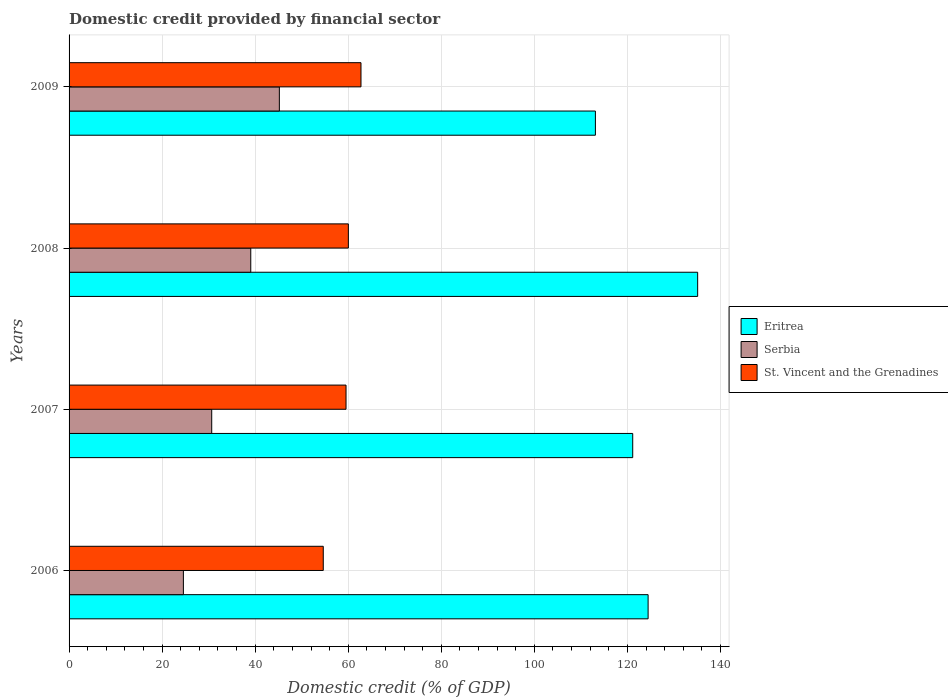How many different coloured bars are there?
Your answer should be compact. 3. How many groups of bars are there?
Provide a succinct answer. 4. Are the number of bars per tick equal to the number of legend labels?
Ensure brevity in your answer.  Yes. How many bars are there on the 4th tick from the top?
Offer a very short reply. 3. What is the label of the 1st group of bars from the top?
Keep it short and to the point. 2009. In how many cases, is the number of bars for a given year not equal to the number of legend labels?
Provide a succinct answer. 0. What is the domestic credit in Serbia in 2006?
Keep it short and to the point. 24.57. Across all years, what is the maximum domestic credit in Serbia?
Give a very brief answer. 45.2. Across all years, what is the minimum domestic credit in Eritrea?
Offer a very short reply. 113.12. What is the total domestic credit in Serbia in the graph?
Keep it short and to the point. 139.47. What is the difference between the domestic credit in Eritrea in 2008 and that in 2009?
Offer a very short reply. 21.98. What is the difference between the domestic credit in Eritrea in 2009 and the domestic credit in St. Vincent and the Grenadines in 2007?
Make the answer very short. 53.6. What is the average domestic credit in Eritrea per year?
Offer a very short reply. 123.45. In the year 2008, what is the difference between the domestic credit in Serbia and domestic credit in Eritrea?
Your response must be concise. -96.05. In how many years, is the domestic credit in Eritrea greater than 32 %?
Keep it short and to the point. 4. What is the ratio of the domestic credit in Serbia in 2008 to that in 2009?
Provide a succinct answer. 0.86. Is the difference between the domestic credit in Serbia in 2008 and 2009 greater than the difference between the domestic credit in Eritrea in 2008 and 2009?
Your answer should be very brief. No. What is the difference between the highest and the second highest domestic credit in Serbia?
Give a very brief answer. 6.14. What is the difference between the highest and the lowest domestic credit in St. Vincent and the Grenadines?
Offer a very short reply. 8.11. What does the 1st bar from the top in 2006 represents?
Ensure brevity in your answer.  St. Vincent and the Grenadines. What does the 1st bar from the bottom in 2007 represents?
Provide a short and direct response. Eritrea. How many bars are there?
Offer a terse response. 12. Does the graph contain any zero values?
Offer a terse response. No. Does the graph contain grids?
Offer a terse response. Yes. How many legend labels are there?
Ensure brevity in your answer.  3. What is the title of the graph?
Offer a terse response. Domestic credit provided by financial sector. Does "Malta" appear as one of the legend labels in the graph?
Give a very brief answer. No. What is the label or title of the X-axis?
Provide a short and direct response. Domestic credit (% of GDP). What is the Domestic credit (% of GDP) in Eritrea in 2006?
Ensure brevity in your answer.  124.45. What is the Domestic credit (% of GDP) of Serbia in 2006?
Provide a short and direct response. 24.57. What is the Domestic credit (% of GDP) of St. Vincent and the Grenadines in 2006?
Give a very brief answer. 54.63. What is the Domestic credit (% of GDP) in Eritrea in 2007?
Keep it short and to the point. 121.14. What is the Domestic credit (% of GDP) of Serbia in 2007?
Provide a short and direct response. 30.66. What is the Domestic credit (% of GDP) in St. Vincent and the Grenadines in 2007?
Your answer should be compact. 59.53. What is the Domestic credit (% of GDP) of Eritrea in 2008?
Offer a very short reply. 135.1. What is the Domestic credit (% of GDP) of Serbia in 2008?
Offer a very short reply. 39.05. What is the Domestic credit (% of GDP) in St. Vincent and the Grenadines in 2008?
Ensure brevity in your answer.  60.03. What is the Domestic credit (% of GDP) in Eritrea in 2009?
Keep it short and to the point. 113.12. What is the Domestic credit (% of GDP) in Serbia in 2009?
Ensure brevity in your answer.  45.2. What is the Domestic credit (% of GDP) in St. Vincent and the Grenadines in 2009?
Provide a succinct answer. 62.74. Across all years, what is the maximum Domestic credit (% of GDP) in Eritrea?
Make the answer very short. 135.1. Across all years, what is the maximum Domestic credit (% of GDP) in Serbia?
Keep it short and to the point. 45.2. Across all years, what is the maximum Domestic credit (% of GDP) in St. Vincent and the Grenadines?
Give a very brief answer. 62.74. Across all years, what is the minimum Domestic credit (% of GDP) of Eritrea?
Ensure brevity in your answer.  113.12. Across all years, what is the minimum Domestic credit (% of GDP) in Serbia?
Give a very brief answer. 24.57. Across all years, what is the minimum Domestic credit (% of GDP) in St. Vincent and the Grenadines?
Your answer should be compact. 54.63. What is the total Domestic credit (% of GDP) in Eritrea in the graph?
Make the answer very short. 493.82. What is the total Domestic credit (% of GDP) of Serbia in the graph?
Your answer should be very brief. 139.47. What is the total Domestic credit (% of GDP) in St. Vincent and the Grenadines in the graph?
Your response must be concise. 236.93. What is the difference between the Domestic credit (% of GDP) in Eritrea in 2006 and that in 2007?
Provide a succinct answer. 3.31. What is the difference between the Domestic credit (% of GDP) of Serbia in 2006 and that in 2007?
Offer a terse response. -6.09. What is the difference between the Domestic credit (% of GDP) in St. Vincent and the Grenadines in 2006 and that in 2007?
Provide a short and direct response. -4.89. What is the difference between the Domestic credit (% of GDP) in Eritrea in 2006 and that in 2008?
Provide a succinct answer. -10.65. What is the difference between the Domestic credit (% of GDP) in Serbia in 2006 and that in 2008?
Provide a succinct answer. -14.48. What is the difference between the Domestic credit (% of GDP) of St. Vincent and the Grenadines in 2006 and that in 2008?
Your answer should be very brief. -5.39. What is the difference between the Domestic credit (% of GDP) in Eritrea in 2006 and that in 2009?
Make the answer very short. 11.32. What is the difference between the Domestic credit (% of GDP) in Serbia in 2006 and that in 2009?
Your answer should be very brief. -20.63. What is the difference between the Domestic credit (% of GDP) of St. Vincent and the Grenadines in 2006 and that in 2009?
Give a very brief answer. -8.11. What is the difference between the Domestic credit (% of GDP) in Eritrea in 2007 and that in 2008?
Your answer should be very brief. -13.96. What is the difference between the Domestic credit (% of GDP) of Serbia in 2007 and that in 2008?
Give a very brief answer. -8.39. What is the difference between the Domestic credit (% of GDP) in St. Vincent and the Grenadines in 2007 and that in 2008?
Ensure brevity in your answer.  -0.5. What is the difference between the Domestic credit (% of GDP) of Eritrea in 2007 and that in 2009?
Keep it short and to the point. 8.02. What is the difference between the Domestic credit (% of GDP) of Serbia in 2007 and that in 2009?
Your response must be concise. -14.54. What is the difference between the Domestic credit (% of GDP) in St. Vincent and the Grenadines in 2007 and that in 2009?
Your answer should be very brief. -3.22. What is the difference between the Domestic credit (% of GDP) of Eritrea in 2008 and that in 2009?
Make the answer very short. 21.98. What is the difference between the Domestic credit (% of GDP) of Serbia in 2008 and that in 2009?
Give a very brief answer. -6.14. What is the difference between the Domestic credit (% of GDP) of St. Vincent and the Grenadines in 2008 and that in 2009?
Provide a succinct answer. -2.72. What is the difference between the Domestic credit (% of GDP) of Eritrea in 2006 and the Domestic credit (% of GDP) of Serbia in 2007?
Your response must be concise. 93.79. What is the difference between the Domestic credit (% of GDP) in Eritrea in 2006 and the Domestic credit (% of GDP) in St. Vincent and the Grenadines in 2007?
Provide a succinct answer. 64.92. What is the difference between the Domestic credit (% of GDP) in Serbia in 2006 and the Domestic credit (% of GDP) in St. Vincent and the Grenadines in 2007?
Make the answer very short. -34.96. What is the difference between the Domestic credit (% of GDP) in Eritrea in 2006 and the Domestic credit (% of GDP) in Serbia in 2008?
Your answer should be compact. 85.4. What is the difference between the Domestic credit (% of GDP) in Eritrea in 2006 and the Domestic credit (% of GDP) in St. Vincent and the Grenadines in 2008?
Your answer should be compact. 64.42. What is the difference between the Domestic credit (% of GDP) of Serbia in 2006 and the Domestic credit (% of GDP) of St. Vincent and the Grenadines in 2008?
Ensure brevity in your answer.  -35.46. What is the difference between the Domestic credit (% of GDP) in Eritrea in 2006 and the Domestic credit (% of GDP) in Serbia in 2009?
Your answer should be compact. 79.25. What is the difference between the Domestic credit (% of GDP) in Eritrea in 2006 and the Domestic credit (% of GDP) in St. Vincent and the Grenadines in 2009?
Give a very brief answer. 61.71. What is the difference between the Domestic credit (% of GDP) of Serbia in 2006 and the Domestic credit (% of GDP) of St. Vincent and the Grenadines in 2009?
Provide a short and direct response. -38.17. What is the difference between the Domestic credit (% of GDP) in Eritrea in 2007 and the Domestic credit (% of GDP) in Serbia in 2008?
Give a very brief answer. 82.09. What is the difference between the Domestic credit (% of GDP) of Eritrea in 2007 and the Domestic credit (% of GDP) of St. Vincent and the Grenadines in 2008?
Your response must be concise. 61.12. What is the difference between the Domestic credit (% of GDP) in Serbia in 2007 and the Domestic credit (% of GDP) in St. Vincent and the Grenadines in 2008?
Make the answer very short. -29.37. What is the difference between the Domestic credit (% of GDP) in Eritrea in 2007 and the Domestic credit (% of GDP) in Serbia in 2009?
Offer a terse response. 75.95. What is the difference between the Domestic credit (% of GDP) in Eritrea in 2007 and the Domestic credit (% of GDP) in St. Vincent and the Grenadines in 2009?
Make the answer very short. 58.4. What is the difference between the Domestic credit (% of GDP) in Serbia in 2007 and the Domestic credit (% of GDP) in St. Vincent and the Grenadines in 2009?
Provide a short and direct response. -32.08. What is the difference between the Domestic credit (% of GDP) in Eritrea in 2008 and the Domestic credit (% of GDP) in Serbia in 2009?
Your answer should be compact. 89.9. What is the difference between the Domestic credit (% of GDP) in Eritrea in 2008 and the Domestic credit (% of GDP) in St. Vincent and the Grenadines in 2009?
Provide a short and direct response. 72.36. What is the difference between the Domestic credit (% of GDP) of Serbia in 2008 and the Domestic credit (% of GDP) of St. Vincent and the Grenadines in 2009?
Your response must be concise. -23.69. What is the average Domestic credit (% of GDP) of Eritrea per year?
Ensure brevity in your answer.  123.45. What is the average Domestic credit (% of GDP) of Serbia per year?
Your answer should be very brief. 34.87. What is the average Domestic credit (% of GDP) in St. Vincent and the Grenadines per year?
Offer a very short reply. 59.23. In the year 2006, what is the difference between the Domestic credit (% of GDP) in Eritrea and Domestic credit (% of GDP) in Serbia?
Make the answer very short. 99.88. In the year 2006, what is the difference between the Domestic credit (% of GDP) of Eritrea and Domestic credit (% of GDP) of St. Vincent and the Grenadines?
Make the answer very short. 69.82. In the year 2006, what is the difference between the Domestic credit (% of GDP) in Serbia and Domestic credit (% of GDP) in St. Vincent and the Grenadines?
Provide a succinct answer. -30.06. In the year 2007, what is the difference between the Domestic credit (% of GDP) in Eritrea and Domestic credit (% of GDP) in Serbia?
Offer a terse response. 90.48. In the year 2007, what is the difference between the Domestic credit (% of GDP) of Eritrea and Domestic credit (% of GDP) of St. Vincent and the Grenadines?
Your answer should be very brief. 61.62. In the year 2007, what is the difference between the Domestic credit (% of GDP) in Serbia and Domestic credit (% of GDP) in St. Vincent and the Grenadines?
Your response must be concise. -28.87. In the year 2008, what is the difference between the Domestic credit (% of GDP) of Eritrea and Domestic credit (% of GDP) of Serbia?
Your answer should be compact. 96.05. In the year 2008, what is the difference between the Domestic credit (% of GDP) in Eritrea and Domestic credit (% of GDP) in St. Vincent and the Grenadines?
Offer a very short reply. 75.07. In the year 2008, what is the difference between the Domestic credit (% of GDP) of Serbia and Domestic credit (% of GDP) of St. Vincent and the Grenadines?
Your response must be concise. -20.98. In the year 2009, what is the difference between the Domestic credit (% of GDP) of Eritrea and Domestic credit (% of GDP) of Serbia?
Keep it short and to the point. 67.93. In the year 2009, what is the difference between the Domestic credit (% of GDP) of Eritrea and Domestic credit (% of GDP) of St. Vincent and the Grenadines?
Give a very brief answer. 50.38. In the year 2009, what is the difference between the Domestic credit (% of GDP) in Serbia and Domestic credit (% of GDP) in St. Vincent and the Grenadines?
Your answer should be compact. -17.55. What is the ratio of the Domestic credit (% of GDP) of Eritrea in 2006 to that in 2007?
Offer a very short reply. 1.03. What is the ratio of the Domestic credit (% of GDP) of Serbia in 2006 to that in 2007?
Provide a short and direct response. 0.8. What is the ratio of the Domestic credit (% of GDP) in St. Vincent and the Grenadines in 2006 to that in 2007?
Give a very brief answer. 0.92. What is the ratio of the Domestic credit (% of GDP) in Eritrea in 2006 to that in 2008?
Ensure brevity in your answer.  0.92. What is the ratio of the Domestic credit (% of GDP) of Serbia in 2006 to that in 2008?
Offer a very short reply. 0.63. What is the ratio of the Domestic credit (% of GDP) of St. Vincent and the Grenadines in 2006 to that in 2008?
Keep it short and to the point. 0.91. What is the ratio of the Domestic credit (% of GDP) of Eritrea in 2006 to that in 2009?
Offer a terse response. 1.1. What is the ratio of the Domestic credit (% of GDP) in Serbia in 2006 to that in 2009?
Provide a succinct answer. 0.54. What is the ratio of the Domestic credit (% of GDP) in St. Vincent and the Grenadines in 2006 to that in 2009?
Your answer should be compact. 0.87. What is the ratio of the Domestic credit (% of GDP) in Eritrea in 2007 to that in 2008?
Make the answer very short. 0.9. What is the ratio of the Domestic credit (% of GDP) of Serbia in 2007 to that in 2008?
Give a very brief answer. 0.79. What is the ratio of the Domestic credit (% of GDP) in St. Vincent and the Grenadines in 2007 to that in 2008?
Provide a short and direct response. 0.99. What is the ratio of the Domestic credit (% of GDP) of Eritrea in 2007 to that in 2009?
Provide a succinct answer. 1.07. What is the ratio of the Domestic credit (% of GDP) of Serbia in 2007 to that in 2009?
Provide a short and direct response. 0.68. What is the ratio of the Domestic credit (% of GDP) in St. Vincent and the Grenadines in 2007 to that in 2009?
Your answer should be compact. 0.95. What is the ratio of the Domestic credit (% of GDP) in Eritrea in 2008 to that in 2009?
Your answer should be compact. 1.19. What is the ratio of the Domestic credit (% of GDP) of Serbia in 2008 to that in 2009?
Make the answer very short. 0.86. What is the ratio of the Domestic credit (% of GDP) of St. Vincent and the Grenadines in 2008 to that in 2009?
Your response must be concise. 0.96. What is the difference between the highest and the second highest Domestic credit (% of GDP) of Eritrea?
Ensure brevity in your answer.  10.65. What is the difference between the highest and the second highest Domestic credit (% of GDP) of Serbia?
Offer a very short reply. 6.14. What is the difference between the highest and the second highest Domestic credit (% of GDP) in St. Vincent and the Grenadines?
Offer a very short reply. 2.72. What is the difference between the highest and the lowest Domestic credit (% of GDP) of Eritrea?
Provide a succinct answer. 21.98. What is the difference between the highest and the lowest Domestic credit (% of GDP) in Serbia?
Provide a succinct answer. 20.63. What is the difference between the highest and the lowest Domestic credit (% of GDP) of St. Vincent and the Grenadines?
Your answer should be very brief. 8.11. 